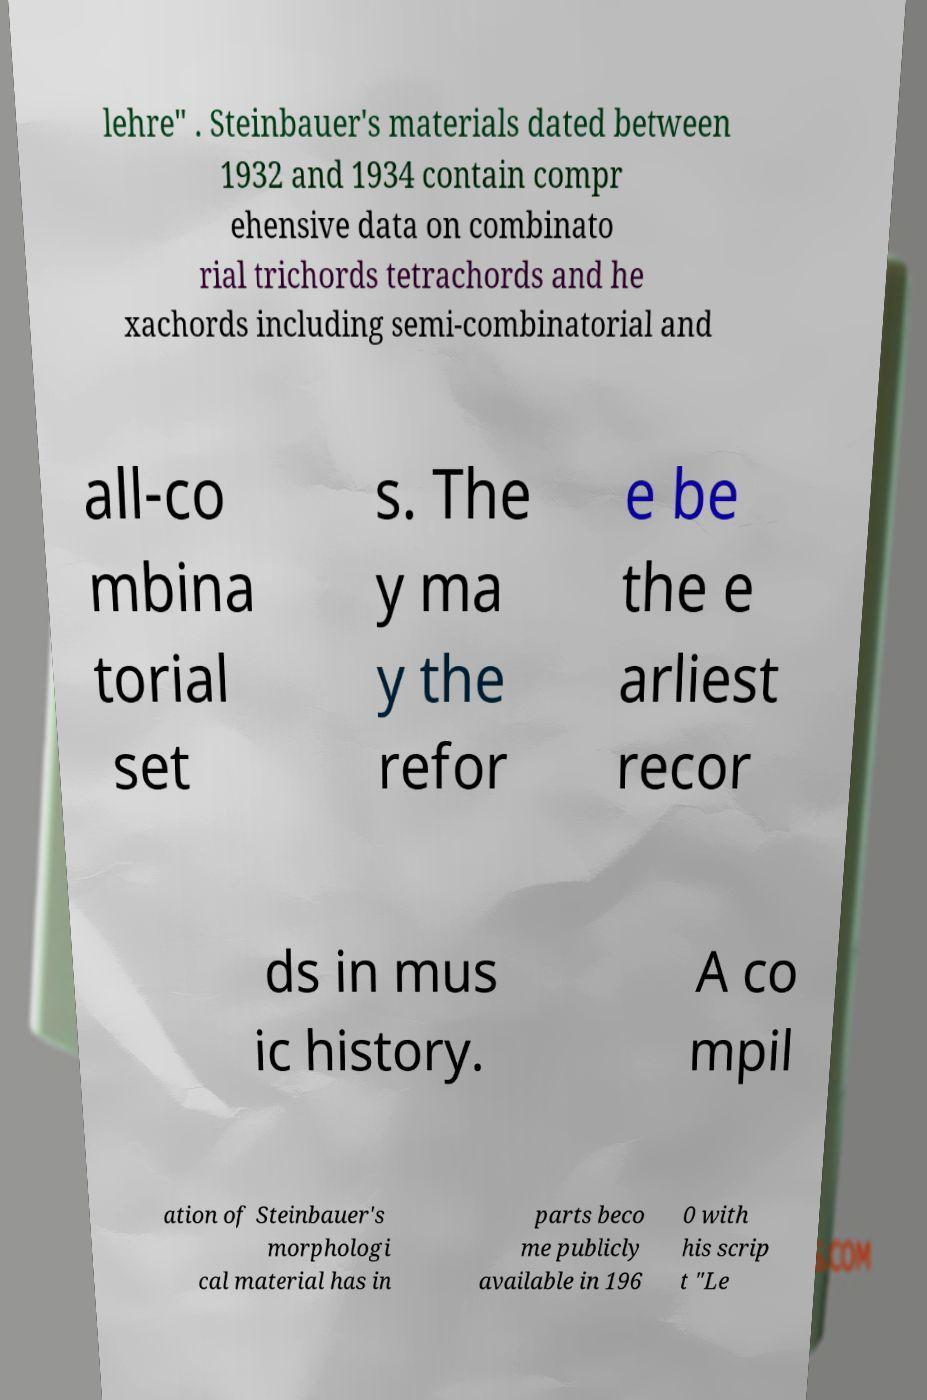What messages or text are displayed in this image? I need them in a readable, typed format. lehre" . Steinbauer's materials dated between 1932 and 1934 contain compr ehensive data on combinato rial trichords tetrachords and he xachords including semi-combinatorial and all-co mbina torial set s. The y ma y the refor e be the e arliest recor ds in mus ic history. A co mpil ation of Steinbauer's morphologi cal material has in parts beco me publicly available in 196 0 with his scrip t "Le 